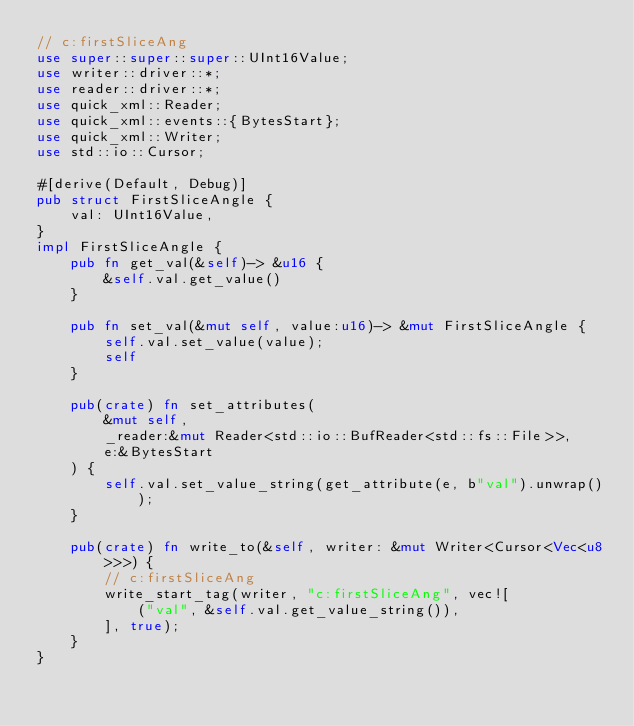<code> <loc_0><loc_0><loc_500><loc_500><_Rust_>// c:firstSliceAng
use super::super::super::UInt16Value;
use writer::driver::*;
use reader::driver::*;
use quick_xml::Reader;
use quick_xml::events::{BytesStart};
use quick_xml::Writer;
use std::io::Cursor;

#[derive(Default, Debug)]
pub struct FirstSliceAngle {
    val: UInt16Value,
}
impl FirstSliceAngle {
    pub fn get_val(&self)-> &u16 {
        &self.val.get_value()
    }
    
    pub fn set_val(&mut self, value:u16)-> &mut FirstSliceAngle {
        self.val.set_value(value);
        self
    }

    pub(crate) fn set_attributes(
        &mut self,
        _reader:&mut Reader<std::io::BufReader<std::fs::File>>,
        e:&BytesStart
    ) {
        self.val.set_value_string(get_attribute(e, b"val").unwrap());
    }

    pub(crate) fn write_to(&self, writer: &mut Writer<Cursor<Vec<u8>>>) {
        // c:firstSliceAng
        write_start_tag(writer, "c:firstSliceAng", vec![
            ("val", &self.val.get_value_string()),
        ], true);
    }
}
</code> 